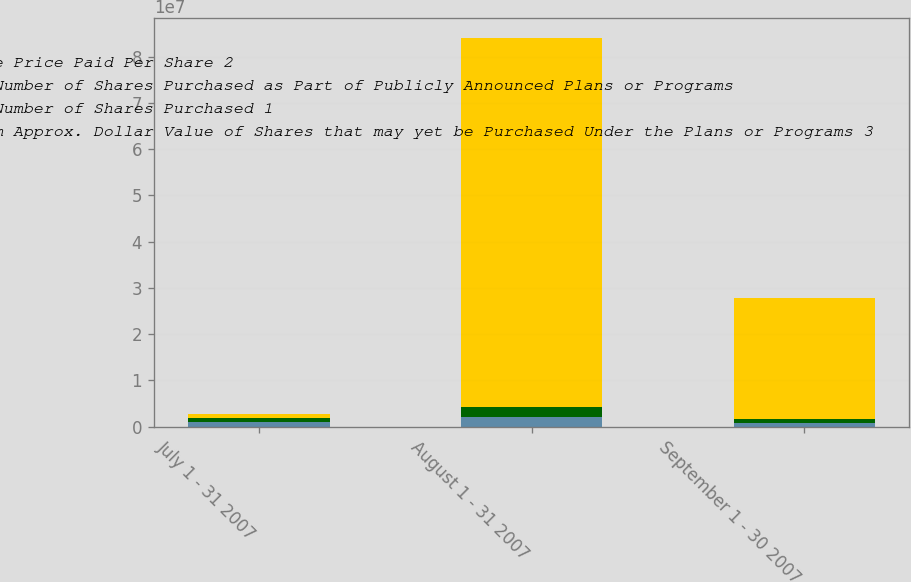Convert chart to OTSL. <chart><loc_0><loc_0><loc_500><loc_500><stacked_bar_chart><ecel><fcel>July 1 - 31 2007<fcel>August 1 - 31 2007<fcel>September 1 - 30 2007<nl><fcel>Average Price Paid Per Share 2<fcel>870000<fcel>2.0606e+06<fcel>778840<nl><fcel>Total Number of Shares Purchased as Part of Publicly Announced Plans or Programs<fcel>72.33<fcel>68.56<fcel>68.9<nl><fcel>Total Number of Shares Purchased 1<fcel>870000<fcel>2.0606e+06<fcel>777938<nl><fcel>Maximum Approx. Dollar Value of Shares that may yet be Purchased Under the Plans or Programs 3<fcel>870000<fcel>7.99176e+07<fcel>2.63233e+07<nl></chart> 